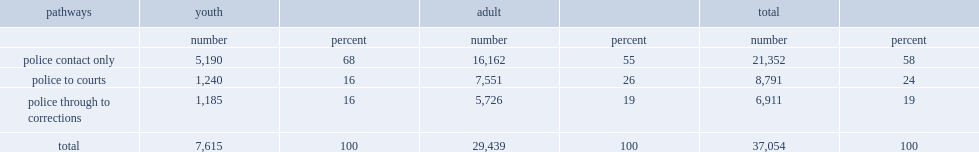What's the percentage of people only had contact with police. 58.0. What's the percentage of people moved through the entire system, from policing to courts and through to corrections. 19.0. 